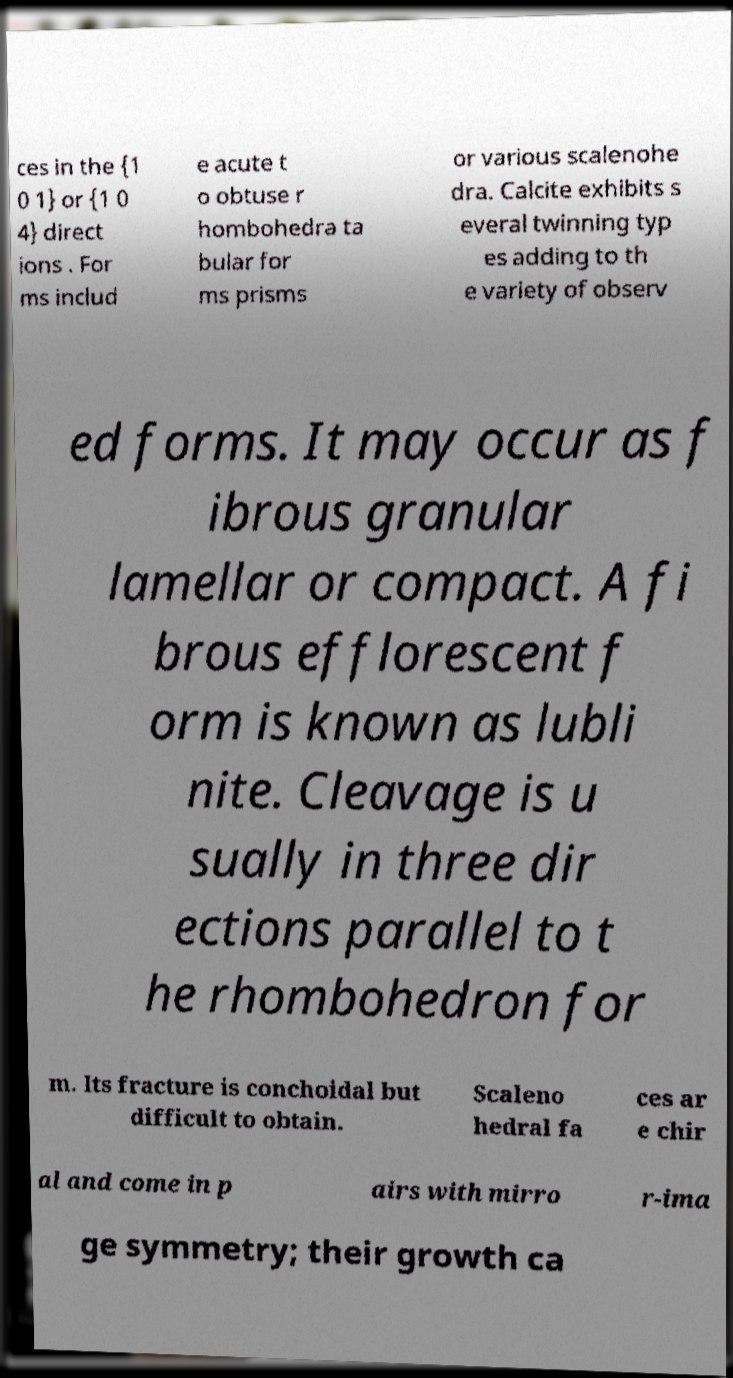Could you assist in decoding the text presented in this image and type it out clearly? ces in the {1 0 1} or {1 0 4} direct ions . For ms includ e acute t o obtuse r hombohedra ta bular for ms prisms or various scalenohe dra. Calcite exhibits s everal twinning typ es adding to th e variety of observ ed forms. It may occur as f ibrous granular lamellar or compact. A fi brous efflorescent f orm is known as lubli nite. Cleavage is u sually in three dir ections parallel to t he rhombohedron for m. Its fracture is conchoidal but difficult to obtain. Scaleno hedral fa ces ar e chir al and come in p airs with mirro r-ima ge symmetry; their growth ca 